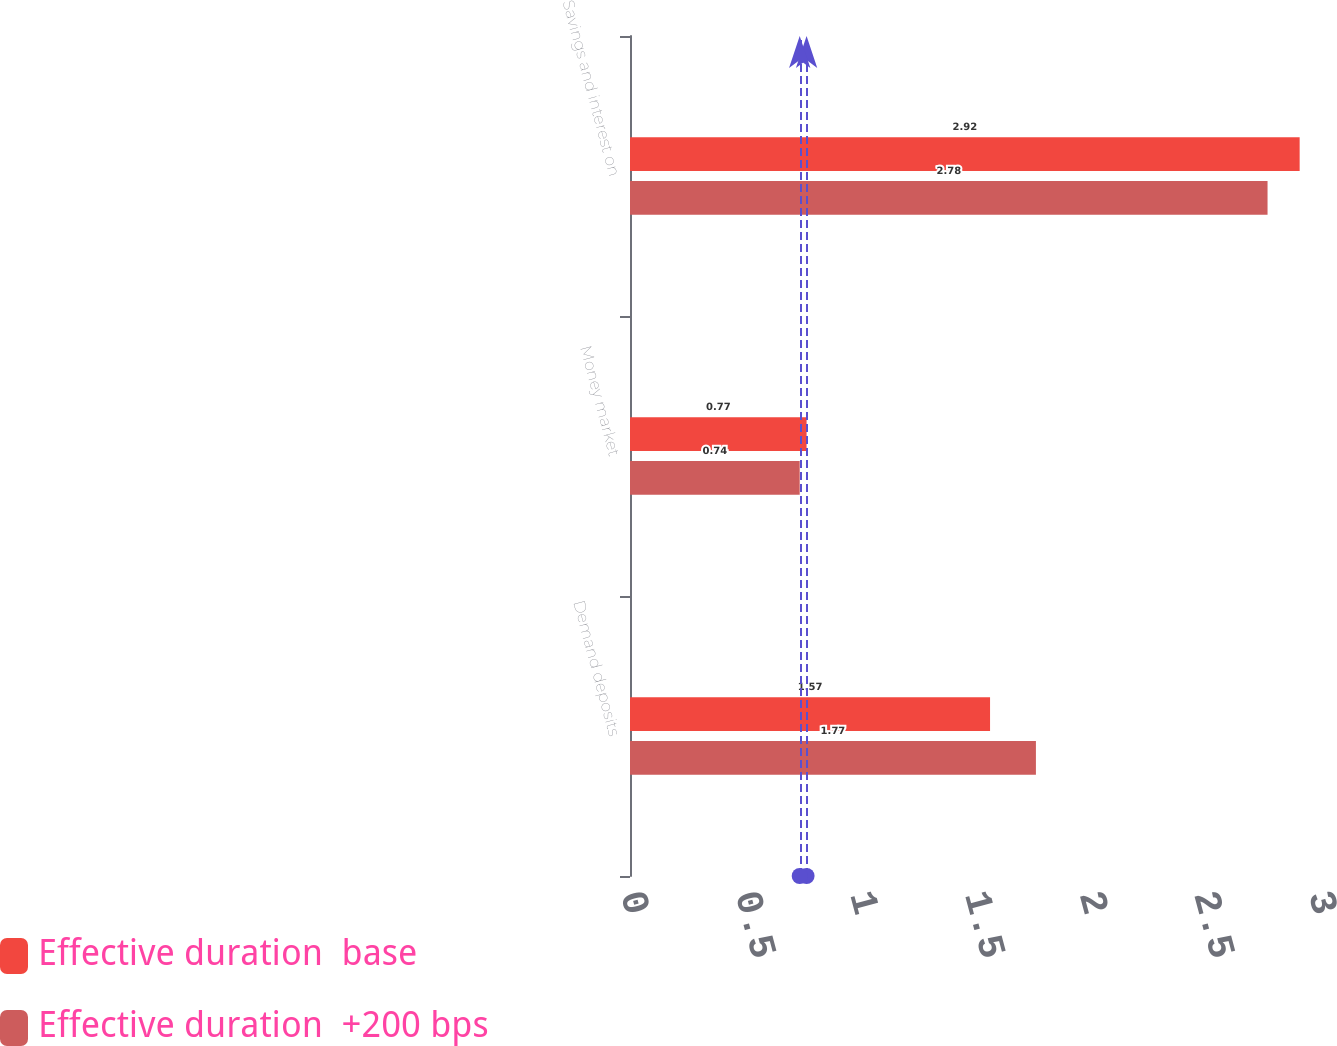Convert chart to OTSL. <chart><loc_0><loc_0><loc_500><loc_500><stacked_bar_chart><ecel><fcel>Demand deposits<fcel>Money market<fcel>Savings and interest on<nl><fcel>Effective duration  base<fcel>1.57<fcel>0.77<fcel>2.92<nl><fcel>Effective duration  +200 bps<fcel>1.77<fcel>0.74<fcel>2.78<nl></chart> 